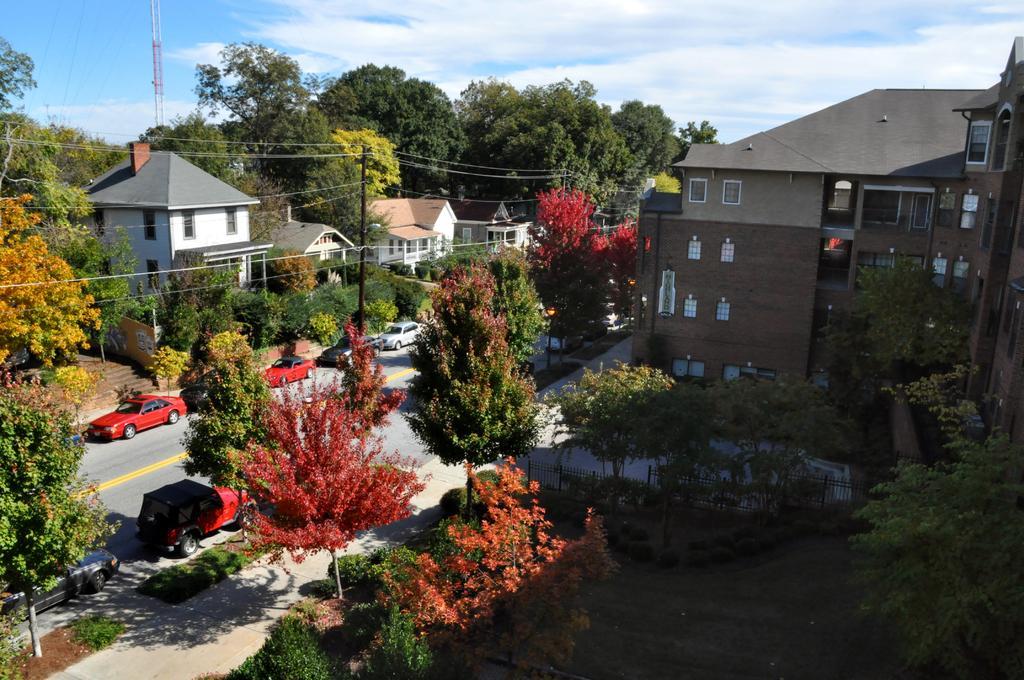Please provide a concise description of this image. In this image, we can see buildings, trees, poles along with wires and there are vehicles on the road. At the top, there are clouds in the sky. 